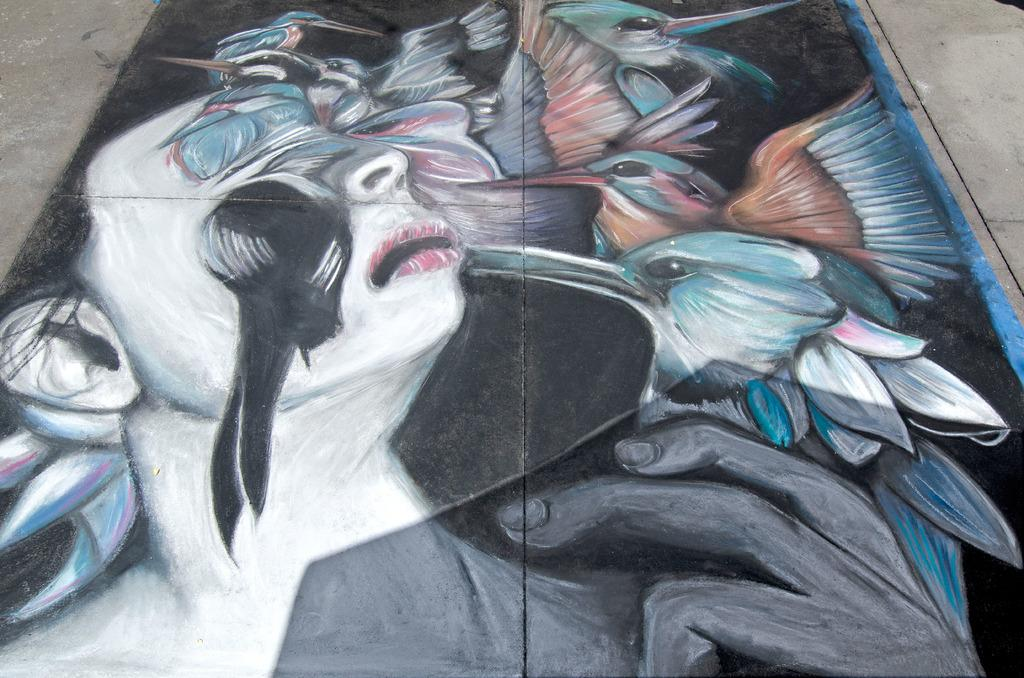What is the main subject of the image? There is a painting in the image. What is depicted in the painting? The painting depicts a person and birds. What type of fang can be seen in the painting? There are no fangs present in the painting; it features a person and birds. What type of trousers is the person wearing in the painting? The painting does not provide enough detail to determine the type of trousers the person is wearing. 